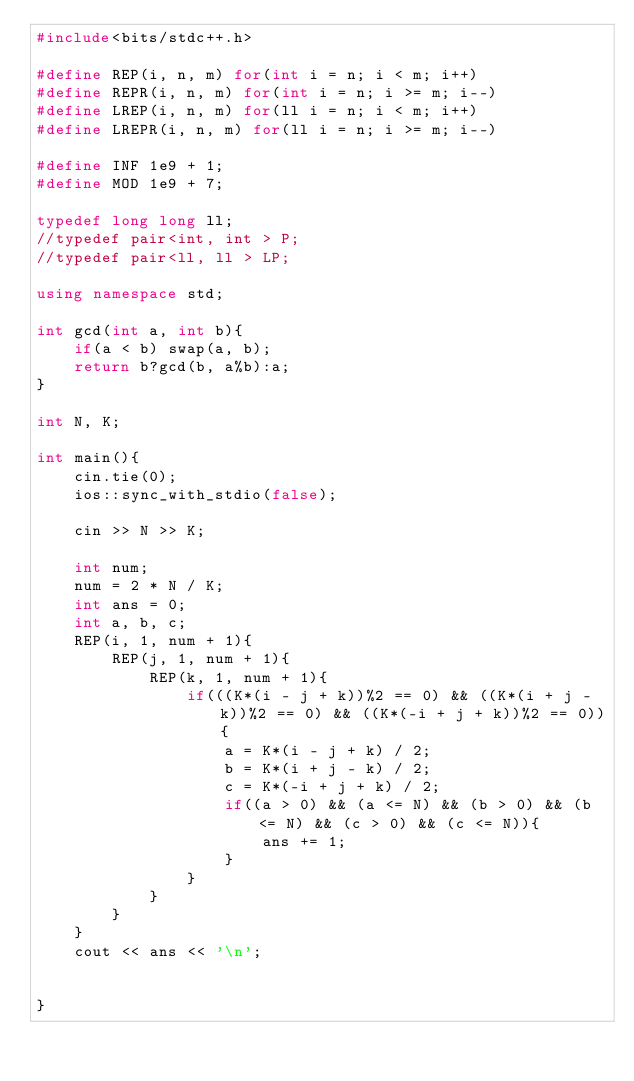<code> <loc_0><loc_0><loc_500><loc_500><_C++_>#include<bits/stdc++.h>

#define REP(i, n, m) for(int i = n; i < m; i++)
#define REPR(i, n, m) for(int i = n; i >= m; i--)
#define LREP(i, n, m) for(ll i = n; i < m; i++)
#define LREPR(i, n, m) for(ll i = n; i >= m; i--)

#define INF 1e9 + 1;
#define MOD 1e9 + 7;

typedef long long ll;
//typedef pair<int, int > P;
//typedef pair<ll, ll > LP;

using namespace std;

int gcd(int a, int b){
    if(a < b) swap(a, b);
    return b?gcd(b, a%b):a;
}

int N, K;

int main(){
    cin.tie(0);
    ios::sync_with_stdio(false);

    cin >> N >> K;

    int num;
    num = 2 * N / K;
    int ans = 0;
    int a, b, c;
    REP(i, 1, num + 1){
        REP(j, 1, num + 1){
            REP(k, 1, num + 1){
                if(((K*(i - j + k))%2 == 0) && ((K*(i + j - k))%2 == 0) && ((K*(-i + j + k))%2 == 0)){
                    a = K*(i - j + k) / 2;
                    b = K*(i + j - k) / 2;
                    c = K*(-i + j + k) / 2;
                    if((a > 0) && (a <= N) && (b > 0) && (b <= N) && (c > 0) && (c <= N)){
                        ans += 1;
                    }
                }
            }
        }
    }
    cout << ans << '\n';


}
</code> 